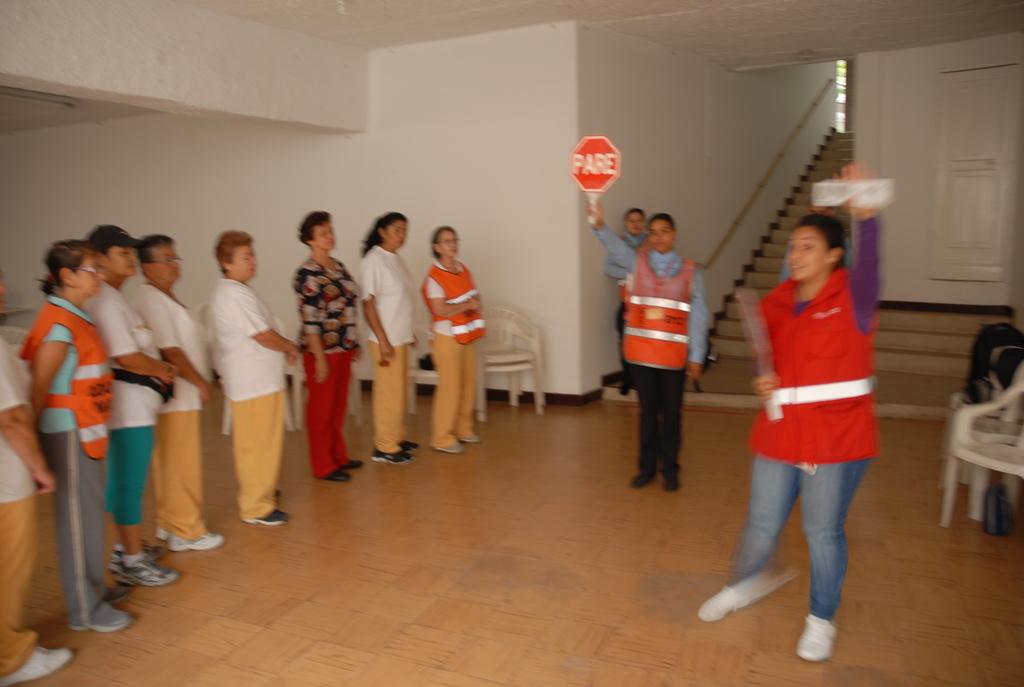What is the meaning of the red sign?
Provide a succinct answer. Pare. 